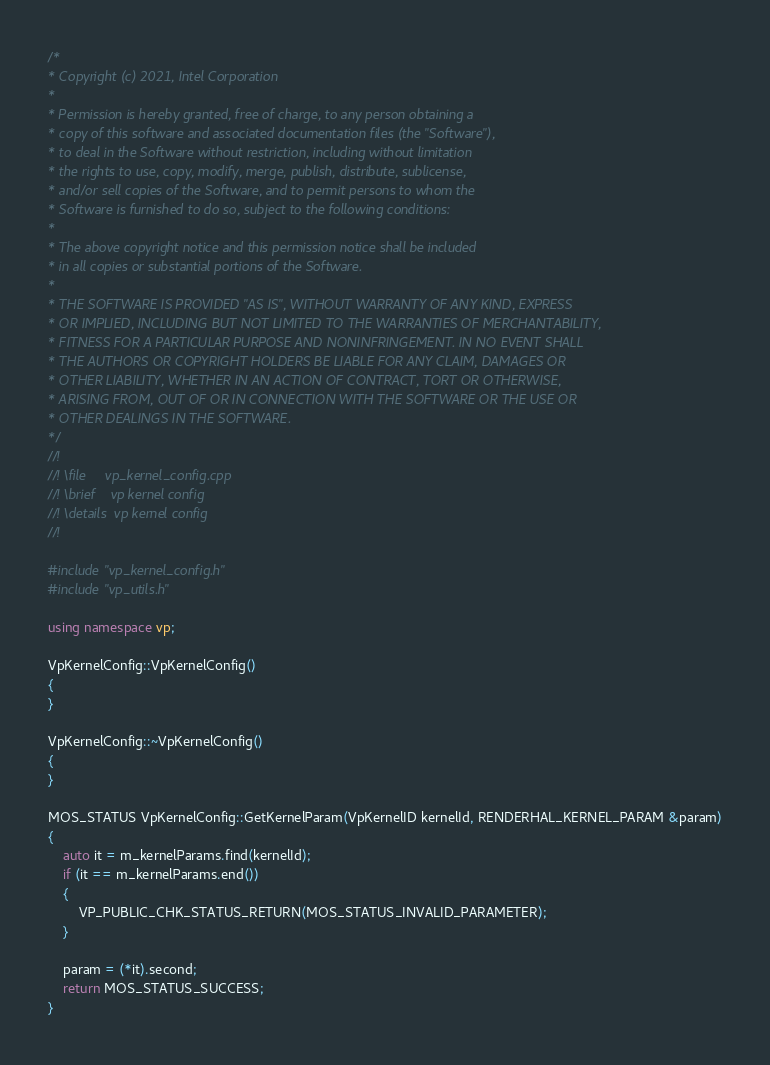Convert code to text. <code><loc_0><loc_0><loc_500><loc_500><_C++_>/*
* Copyright (c) 2021, Intel Corporation
*
* Permission is hereby granted, free of charge, to any person obtaining a
* copy of this software and associated documentation files (the "Software"),
* to deal in the Software without restriction, including without limitation
* the rights to use, copy, modify, merge, publish, distribute, sublicense,
* and/or sell copies of the Software, and to permit persons to whom the
* Software is furnished to do so, subject to the following conditions:
*
* The above copyright notice and this permission notice shall be included
* in all copies or substantial portions of the Software.
*
* THE SOFTWARE IS PROVIDED "AS IS", WITHOUT WARRANTY OF ANY KIND, EXPRESS
* OR IMPLIED, INCLUDING BUT NOT LIMITED TO THE WARRANTIES OF MERCHANTABILITY,
* FITNESS FOR A PARTICULAR PURPOSE AND NONINFRINGEMENT. IN NO EVENT SHALL
* THE AUTHORS OR COPYRIGHT HOLDERS BE LIABLE FOR ANY CLAIM, DAMAGES OR
* OTHER LIABILITY, WHETHER IN AN ACTION OF CONTRACT, TORT OR OTHERWISE,
* ARISING FROM, OUT OF OR IN CONNECTION WITH THE SOFTWARE OR THE USE OR
* OTHER DEALINGS IN THE SOFTWARE.
*/
//!
//! \file     vp_kernel_config.cpp
//! \brief    vp kernel config
//! \details  vp kernel config
//!

#include "vp_kernel_config.h"
#include "vp_utils.h"

using namespace vp;

VpKernelConfig::VpKernelConfig()
{
}

VpKernelConfig::~VpKernelConfig()
{
}

MOS_STATUS VpKernelConfig::GetKernelParam(VpKernelID kernelId, RENDERHAL_KERNEL_PARAM &param)
{
    auto it = m_kernelParams.find(kernelId);
    if (it == m_kernelParams.end())
    {
        VP_PUBLIC_CHK_STATUS_RETURN(MOS_STATUS_INVALID_PARAMETER);
    }

    param = (*it).second;
    return MOS_STATUS_SUCCESS;
}</code> 